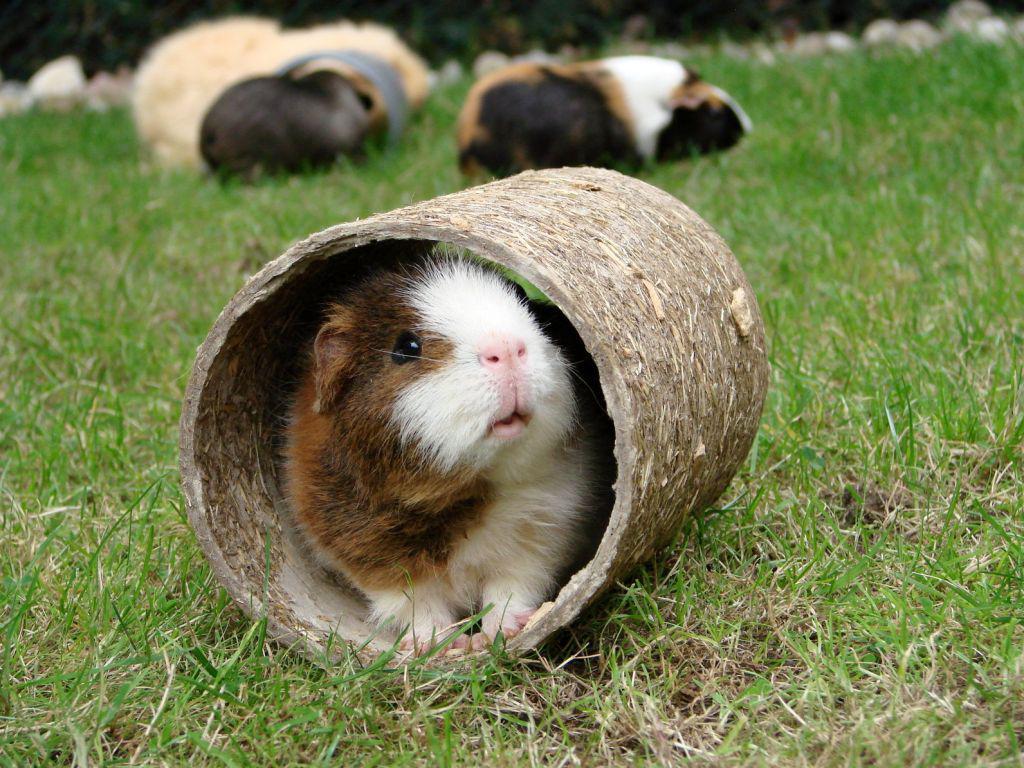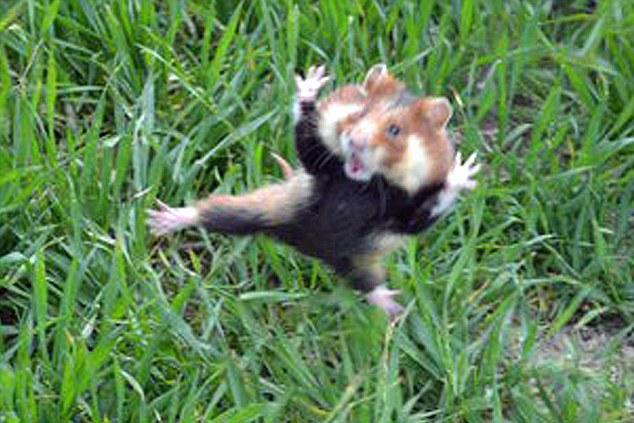The first image is the image on the left, the second image is the image on the right. For the images shown, is this caption "Each image shows exactly one side-by-side pair of guinea pigs posed outdoors on green ground." true? Answer yes or no. No. The first image is the image on the left, the second image is the image on the right. Examine the images to the left and right. Is the description "Two rodents are sitting together in the grass in each of the images." accurate? Answer yes or no. No. 